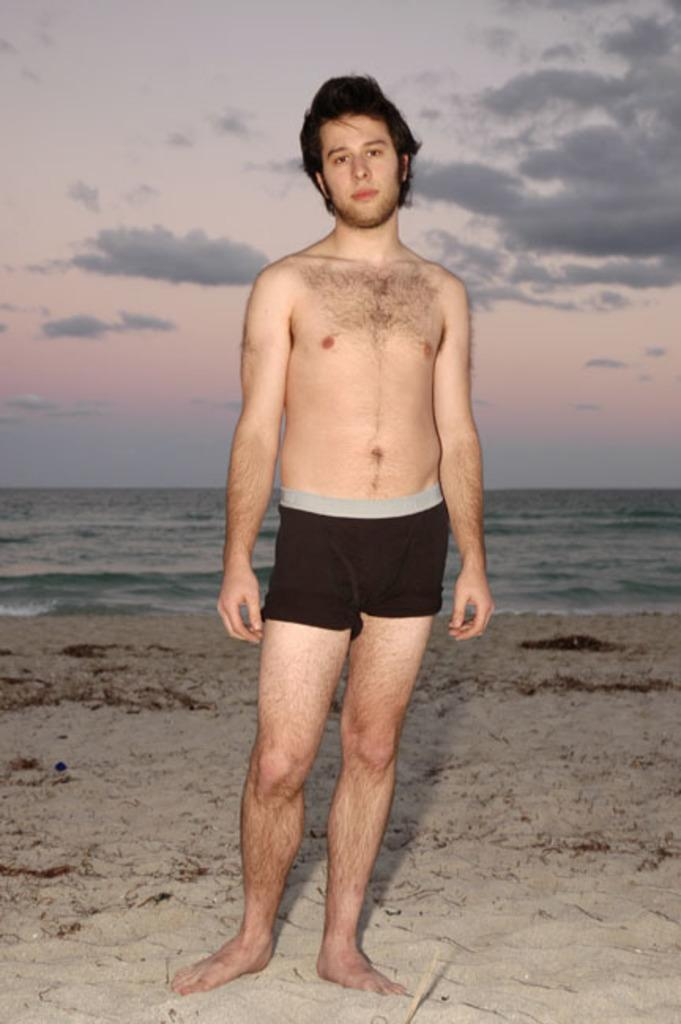What is the main subject of the image? There is a man standing in the image. What type of surface is the man standing on? The man is standing on sand. What can be seen in the background of the image? There is water visible in the background of the image. What is visible in the sky in the image? The sky is visible in the image, and clouds are present. What type of structure can be seen in the middle of the image? There is no structure present in the image; it features a man standing on sand with water and clouds visible in the background. 